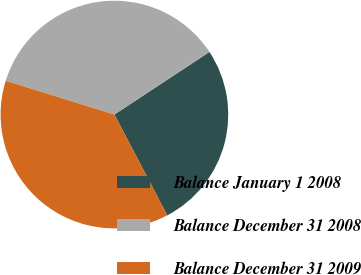Convert chart to OTSL. <chart><loc_0><loc_0><loc_500><loc_500><pie_chart><fcel>Balance January 1 2008<fcel>Balance December 31 2008<fcel>Balance December 31 2009<nl><fcel>26.59%<fcel>35.93%<fcel>37.48%<nl></chart> 